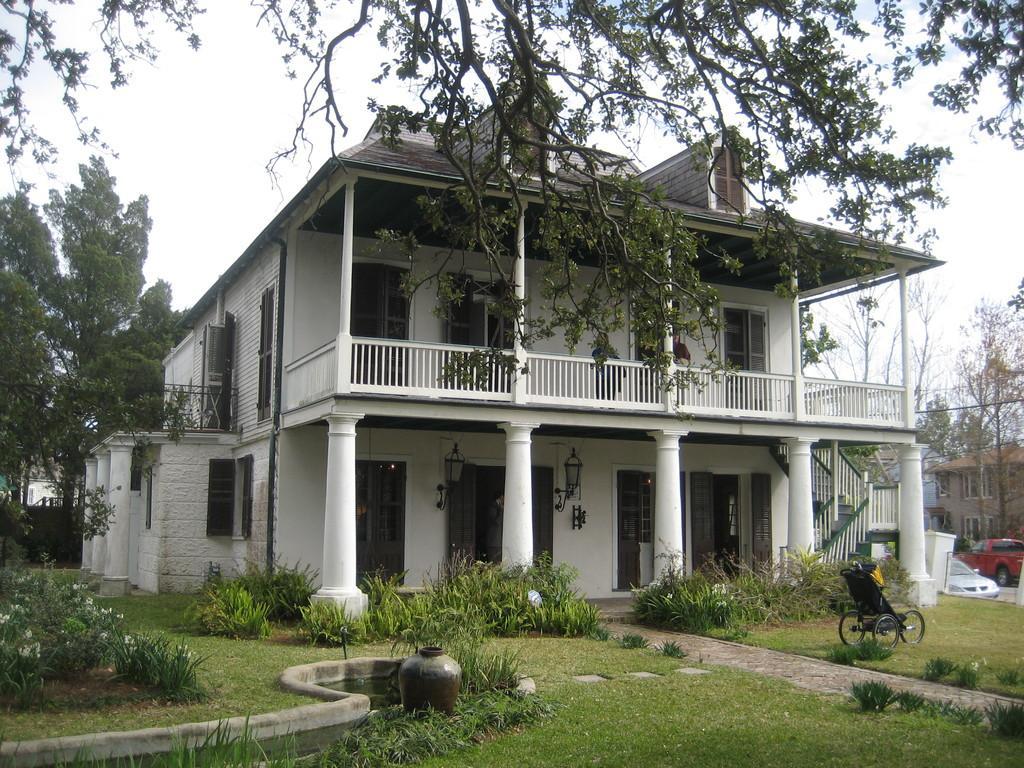Could you give a brief overview of what you see in this image? In this image I can see few buildings, trees, grass, number of plants, windows and I can see few vehicles over there. I can also see a black colour wheelchair over here. 